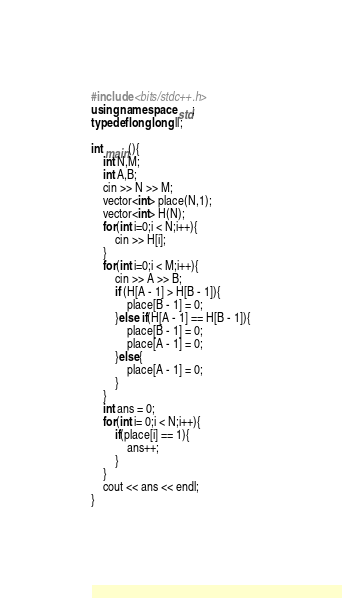Convert code to text. <code><loc_0><loc_0><loc_500><loc_500><_C++_>#include <bits/stdc++.h>
using namespace std;
typedef long long ll;

int main(){
    int N,M;
    int A,B;
    cin >> N >> M;
    vector<int> place(N,1);
    vector<int> H(N);
    for(int i=0;i < N;i++){
        cin >> H[i];
    }
    for(int i=0;i < M;i++){
        cin >> A >> B;
        if (H[A - 1] > H[B - 1]){
            place[B - 1] = 0;
        }else if(H[A - 1] == H[B - 1]){
            place[B - 1] = 0;
            place[A - 1] = 0;
        }else{
            place[A - 1] = 0;
        }
    }
    int ans = 0;
    for(int i= 0;i < N;i++){
        if(place[i] == 1){
            ans++;
        }
    }
    cout << ans << endl;
}</code> 